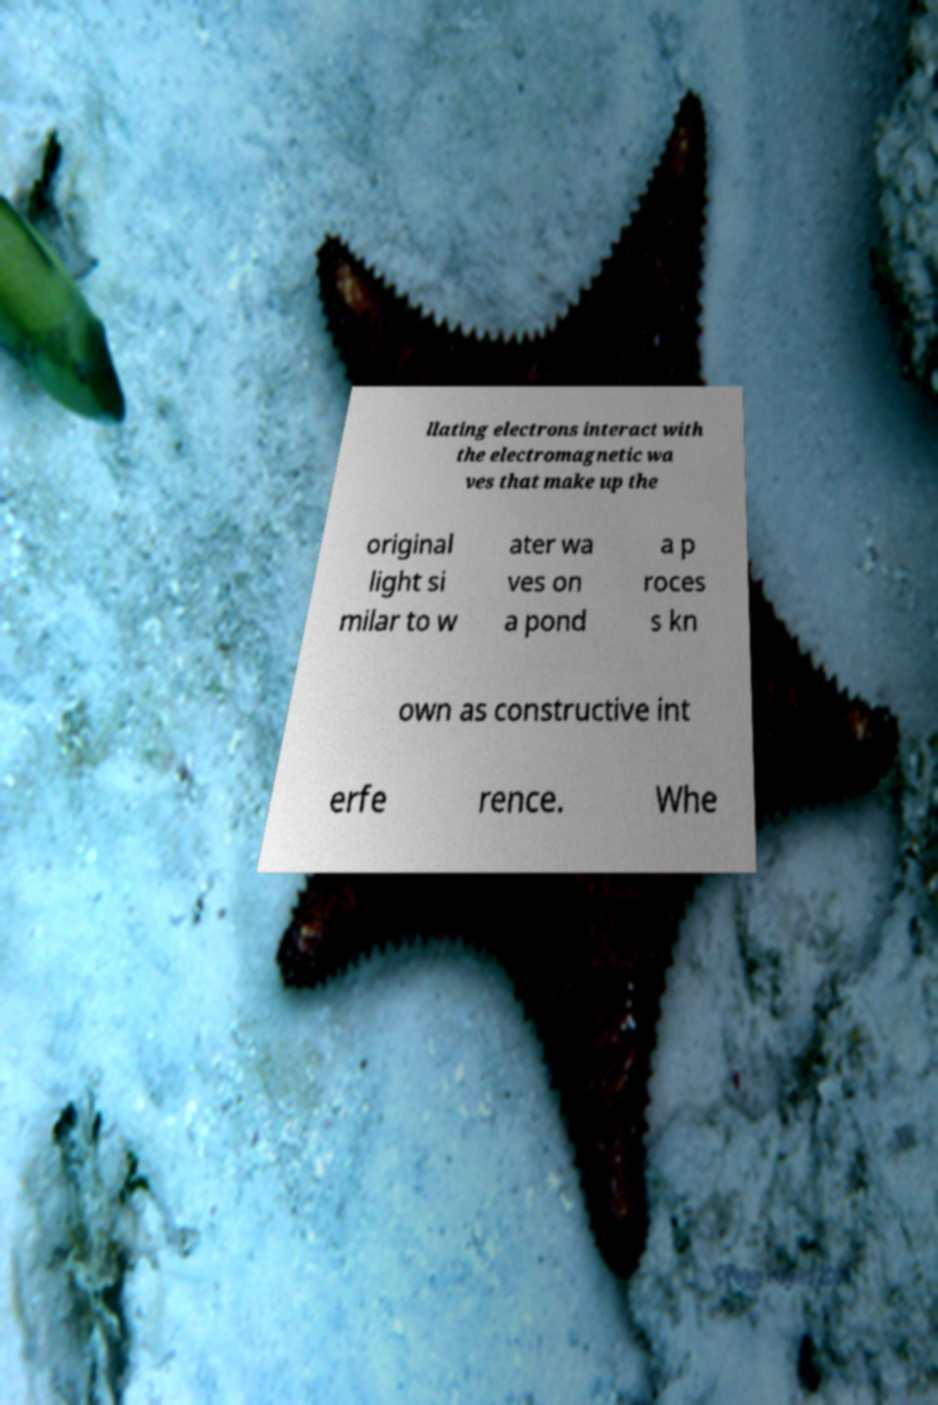There's text embedded in this image that I need extracted. Can you transcribe it verbatim? llating electrons interact with the electromagnetic wa ves that make up the original light si milar to w ater wa ves on a pond a p roces s kn own as constructive int erfe rence. Whe 